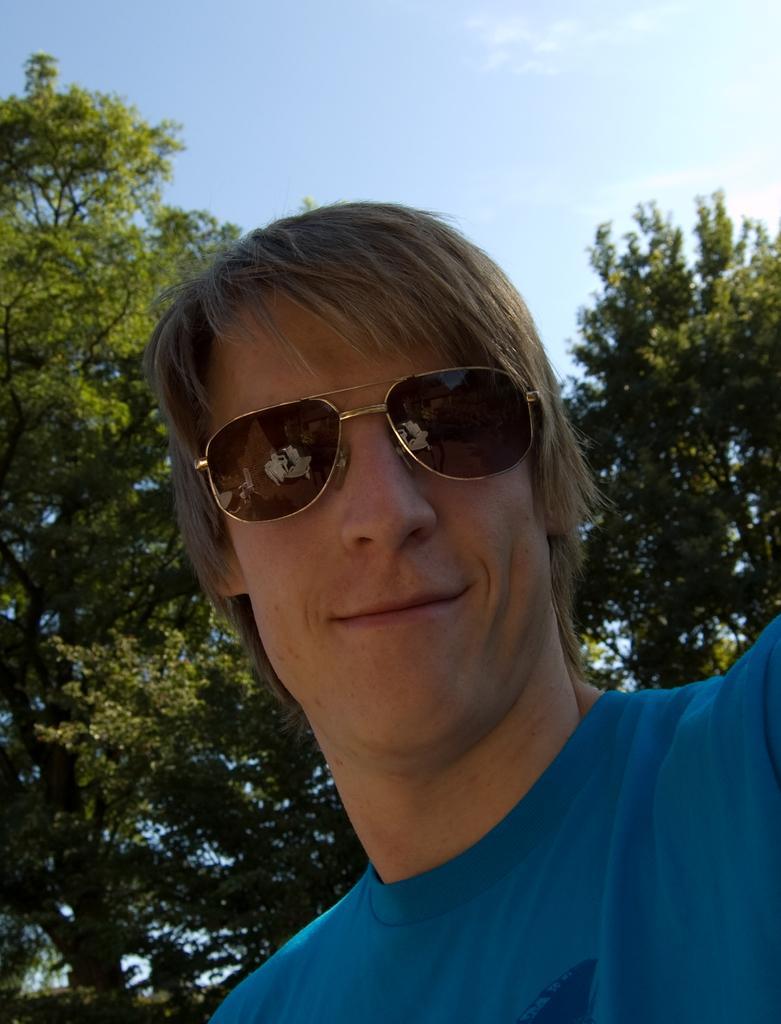Could you give a brief overview of what you see in this image? In this picture we can see a man wore goggles and smiling and in the background we can see trees and the sky. 